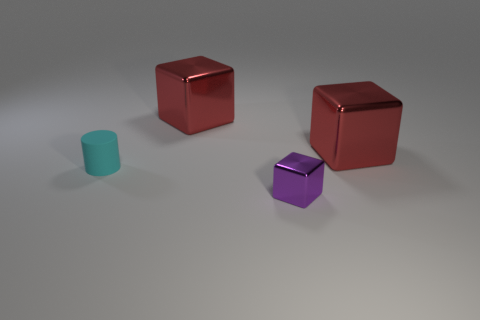There is a object that is both left of the small block and right of the matte cylinder; what is its color?
Make the answer very short. Red. How many things are metallic blocks that are to the left of the tiny metal cube or tiny gray metallic things?
Make the answer very short. 1. There is a tiny purple thing; is its shape the same as the big red metallic object that is to the left of the purple shiny thing?
Provide a short and direct response. Yes. What number of objects are metallic things in front of the tiny matte thing or red things that are behind the tiny purple metallic block?
Provide a succinct answer. 3. Is the number of small shiny objects that are on the right side of the cylinder less than the number of rubber cylinders?
Make the answer very short. No. Do the tiny purple object and the thing that is on the right side of the purple metal object have the same material?
Your response must be concise. Yes. What material is the small cylinder?
Your answer should be very brief. Rubber. There is a purple cube to the right of the rubber cylinder that is behind the small purple metal cube on the right side of the tiny cyan thing; what is it made of?
Keep it short and to the point. Metal. Is there any other thing that is the same shape as the rubber object?
Offer a terse response. No. What is the color of the object that is left of the large red object that is on the left side of the tiny purple metallic object?
Your response must be concise. Cyan. 